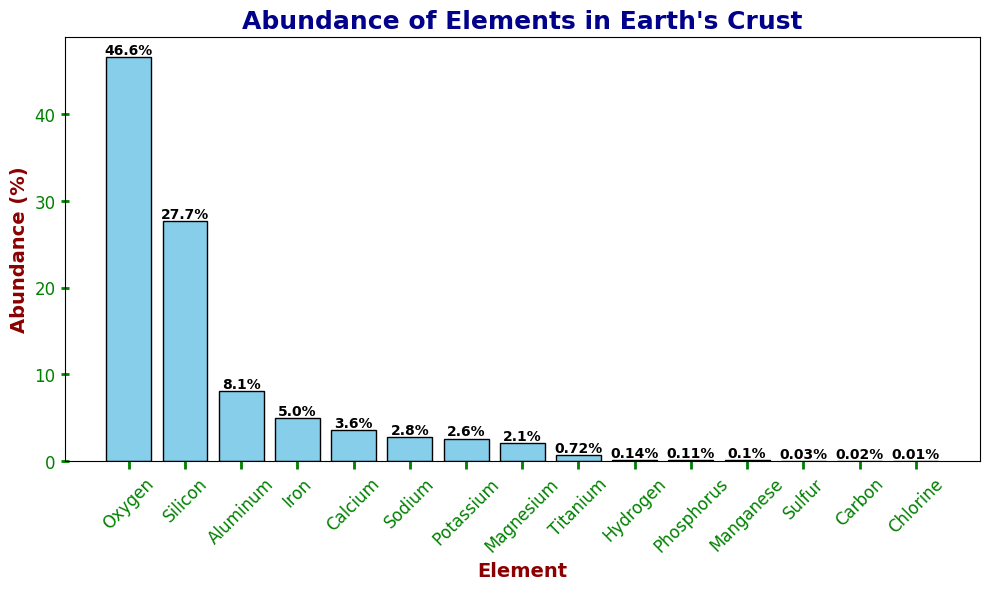What element has the highest abundance in the Earth's crust? By observing the height of the bars, the tallest bar corresponds to Oxygen.
Answer: Oxygen Which is less abundant, Potassium or Sodium? By comparing the heights of the bars for Potassium and Sodium, Potassium has a lower height than Sodium, indicating lower abundance.
Answer: Potassium How much more abundant is Silicon compared to Aluminum? The abundance of Silicon is 27.7% and Aluminum is 8.1%. The difference is 27.7% - 8.1% = 19.6%.
Answer: 19.6% What is the total abundance of the three most abundant elements? The three most abundant elements are Oxygen (46.6%), Silicon (27.7%), and Aluminum (8.1%). Summing these gives 46.6 + 27.7 + 8.1 = 82.4%.
Answer: 82.4% By how much does the abundance of Iron exceed that of Titanium? The abundance of Iron is 5.0% and Titanium is 0.72%. The difference is 5.0% - 0.72% = 4.28%.
Answer: 4.28% What is the total abundance of all elements that are less than 1%? Elements with less than 1% are Hydrogen (0.14%), Phosphorus (0.11%), Manganese (0.1%), Sulfur (0.03%), Carbon (0.02%), and Chlorine (0.01%). Summing these gives 0.14 + 0.11 + 0.1 + 0.03 + 0.02 + 0.01 = 0.41%.
Answer: 0.41% Which element's abundance is closest to 5%? By looking closely at the heights of the bars, Iron has an abundance closest to 5%.
Answer: Iron What is the combined abundance of Sodium and Magnesium? Sodium has an abundance of 2.8% and Magnesium has 2.1%. Summing these gives 2.8 + 2.1 = 4.9%.
Answer: 4.9% By how much does the abundance of Oxygen compare to the combined abundance of Iron and Calcium? The abundance of Oxygen is 46.6%. The combined abundance of Iron (5.0%) and Calcium (3.6%) is 5.0 + 3.6 = 8.6%. The difference is 46.6 - 8.6 = 38.0%.
Answer: 38.0% Which element has the smallest abundance in the Earth's crust? By identifying the shortest bar, Chlorine has the smallest abundance.
Answer: Chlorine 